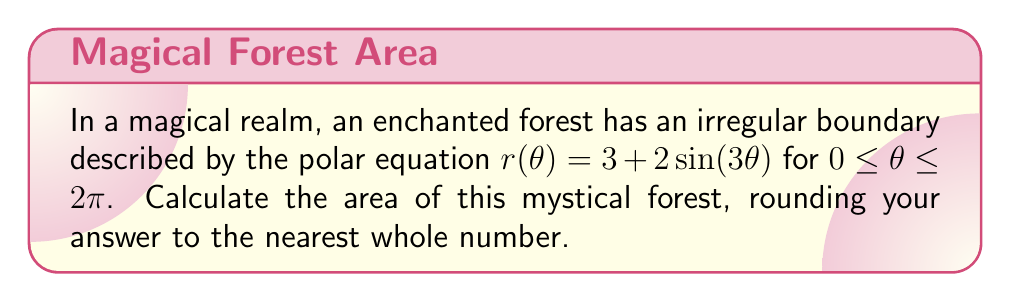Can you solve this math problem? To find the area of this enchanted forest with irregular boundaries, we'll use the formula for the area of a region in polar coordinates:

$$A = \frac{1}{2} \int_{0}^{2\pi} [r(\theta)]^2 d\theta$$

Let's follow these steps:

1) Substitute the given equation into the formula:
   $$A = \frac{1}{2} \int_{0}^{2\pi} [3 + 2\sin(3\theta)]^2 d\theta$$

2) Expand the squared term:
   $$A = \frac{1}{2} \int_{0}^{2\pi} [9 + 12\sin(3\theta) + 4\sin^2(3\theta)] d\theta$$

3) Integrate each term:
   $$A = \frac{1}{2} [9\theta + 12(-\frac{1}{3}\cos(3\theta)) + 4(\frac{\theta}{2} - \frac{\sin(6\theta)}{4})]_{0}^{2\pi}$$

4) Evaluate the integral:
   $$A = \frac{1}{2} [(9 \cdot 2\pi) + 0 + 4(\pi - 0)]$$
   $$A = \frac{1}{2} [18\pi + 4\pi]$$
   $$A = \frac{1}{2} [22\pi]$$
   $$A = 11\pi$$

5) Convert to a numerical value and round to the nearest whole number:
   $$A \approx 34.56 \approx 35$$

Thus, the area of the enchanted forest is approximately 35 square units.
Answer: 35 square units 